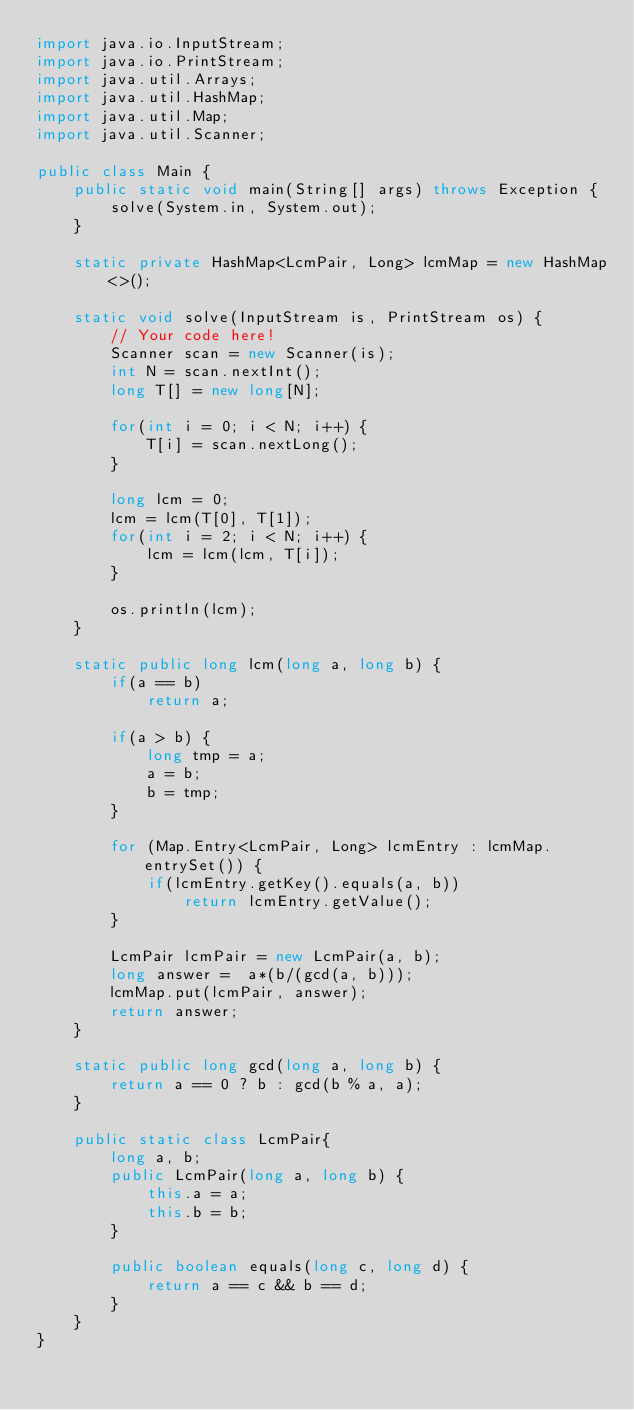Convert code to text. <code><loc_0><loc_0><loc_500><loc_500><_Java_>import java.io.InputStream;
import java.io.PrintStream;
import java.util.Arrays;
import java.util.HashMap;
import java.util.Map;
import java.util.Scanner;

public class Main {
    public static void main(String[] args) throws Exception {
        solve(System.in, System.out);
    }

    static private HashMap<LcmPair, Long> lcmMap = new HashMap<>();

    static void solve(InputStream is, PrintStream os) {
        // Your code here!
        Scanner scan = new Scanner(is);
        int N = scan.nextInt();
        long T[] = new long[N];

        for(int i = 0; i < N; i++) {
            T[i] = scan.nextLong();
        }

        long lcm = 0;
        lcm = lcm(T[0], T[1]);
        for(int i = 2; i < N; i++) {
            lcm = lcm(lcm, T[i]);
        }

        os.println(lcm);
    }

    static public long lcm(long a, long b) {
        if(a == b)
            return a;

        if(a > b) {
            long tmp = a;
            a = b;
            b = tmp;
        }

        for (Map.Entry<LcmPair, Long> lcmEntry : lcmMap.entrySet()) {
            if(lcmEntry.getKey().equals(a, b))
                return lcmEntry.getValue();
        }

        LcmPair lcmPair = new LcmPair(a, b);
        long answer =  a*(b/(gcd(a, b)));
        lcmMap.put(lcmPair, answer);
        return answer;
    }

    static public long gcd(long a, long b) {
        return a == 0 ? b : gcd(b % a, a);
    }

    public static class LcmPair{
        long a, b;
        public LcmPair(long a, long b) {
            this.a = a;
            this.b = b;
        }

        public boolean equals(long c, long d) {
            return a == c && b == d;
        }
    }
}</code> 